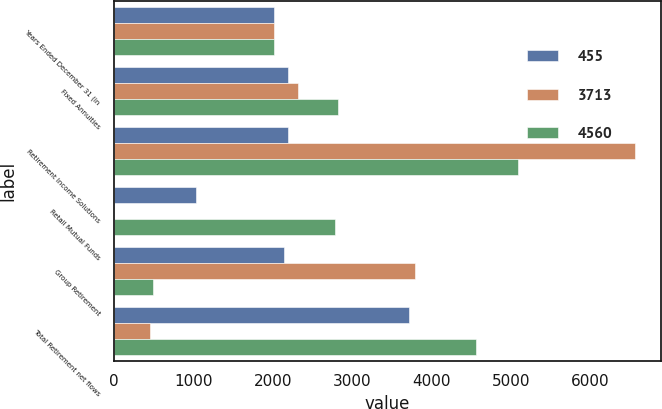Convert chart. <chart><loc_0><loc_0><loc_500><loc_500><stacked_bar_chart><ecel><fcel>Years Ended December 31 (in<fcel>Fixed Annuities<fcel>Retirement Income Solutions<fcel>Retail Mutual Funds<fcel>Group Retirement<fcel>Total Retirement net flows<nl><fcel>455<fcel>2015<fcel>2188<fcel>2188<fcel>1026<fcel>2135<fcel>3713<nl><fcel>3713<fcel>2014<fcel>2313<fcel>6566<fcel>1<fcel>3797<fcel>455<nl><fcel>4560<fcel>2013<fcel>2820<fcel>5092<fcel>2780<fcel>492<fcel>4560<nl></chart> 